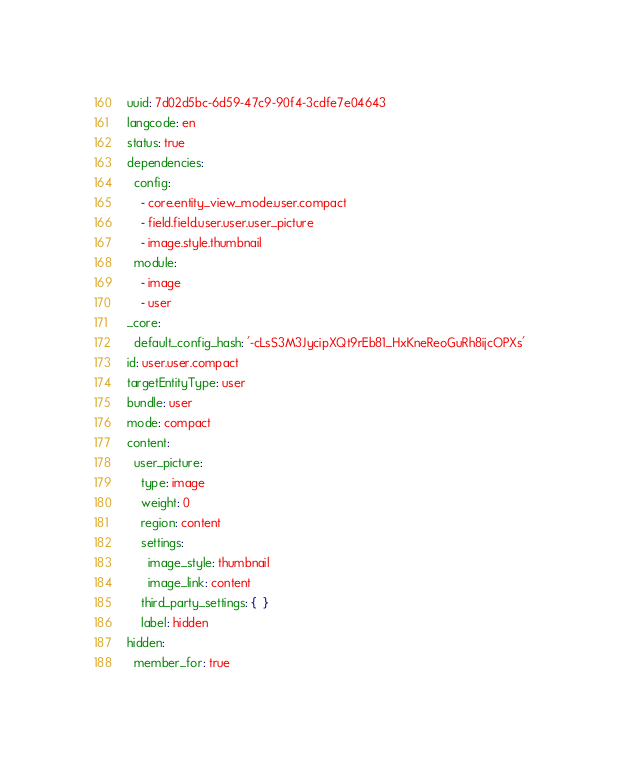<code> <loc_0><loc_0><loc_500><loc_500><_YAML_>uuid: 7d02d5bc-6d59-47c9-90f4-3cdfe7e04643
langcode: en
status: true
dependencies:
  config:
    - core.entity_view_mode.user.compact
    - field.field.user.user.user_picture
    - image.style.thumbnail
  module:
    - image
    - user
_core:
  default_config_hash: '-cLsS3M3JycipXQt9rEb81_HxKneReoGuRh8ijcOPXs'
id: user.user.compact
targetEntityType: user
bundle: user
mode: compact
content:
  user_picture:
    type: image
    weight: 0
    region: content
    settings:
      image_style: thumbnail
      image_link: content
    third_party_settings: {  }
    label: hidden
hidden:
  member_for: true
</code> 